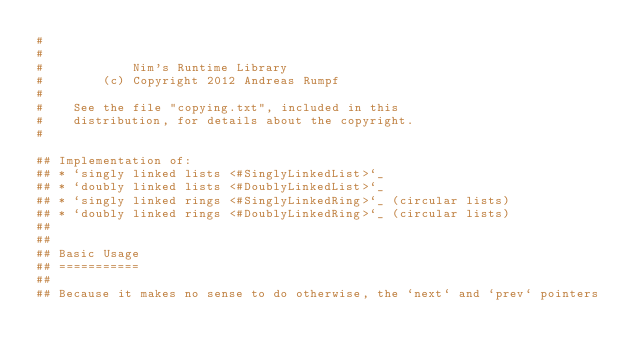<code> <loc_0><loc_0><loc_500><loc_500><_Nim_>#
#
#            Nim's Runtime Library
#        (c) Copyright 2012 Andreas Rumpf
#
#    See the file "copying.txt", included in this
#    distribution, for details about the copyright.
#

## Implementation of:
## * `singly linked lists <#SinglyLinkedList>`_
## * `doubly linked lists <#DoublyLinkedList>`_
## * `singly linked rings <#SinglyLinkedRing>`_ (circular lists)
## * `doubly linked rings <#DoublyLinkedRing>`_ (circular lists)
##
##
## Basic Usage
## ===========
##
## Because it makes no sense to do otherwise, the `next` and `prev` pointers</code> 